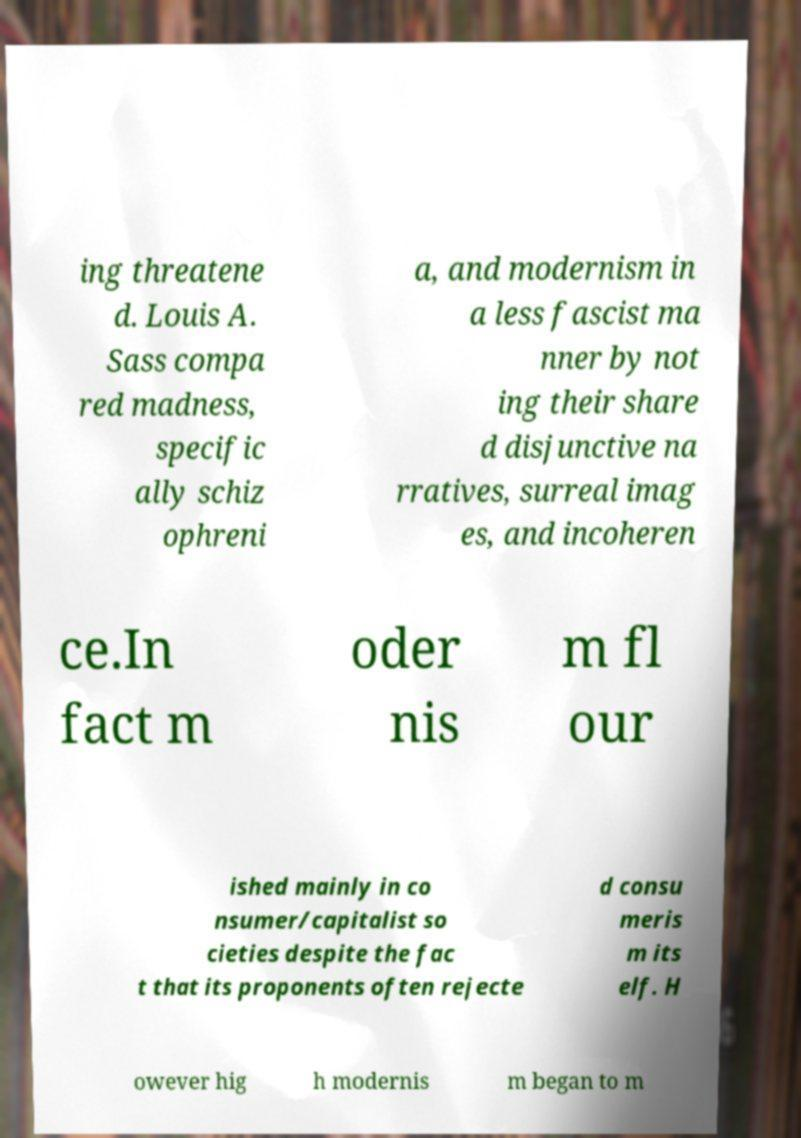Could you assist in decoding the text presented in this image and type it out clearly? ing threatene d. Louis A. Sass compa red madness, specific ally schiz ophreni a, and modernism in a less fascist ma nner by not ing their share d disjunctive na rratives, surreal imag es, and incoheren ce.In fact m oder nis m fl our ished mainly in co nsumer/capitalist so cieties despite the fac t that its proponents often rejecte d consu meris m its elf. H owever hig h modernis m began to m 